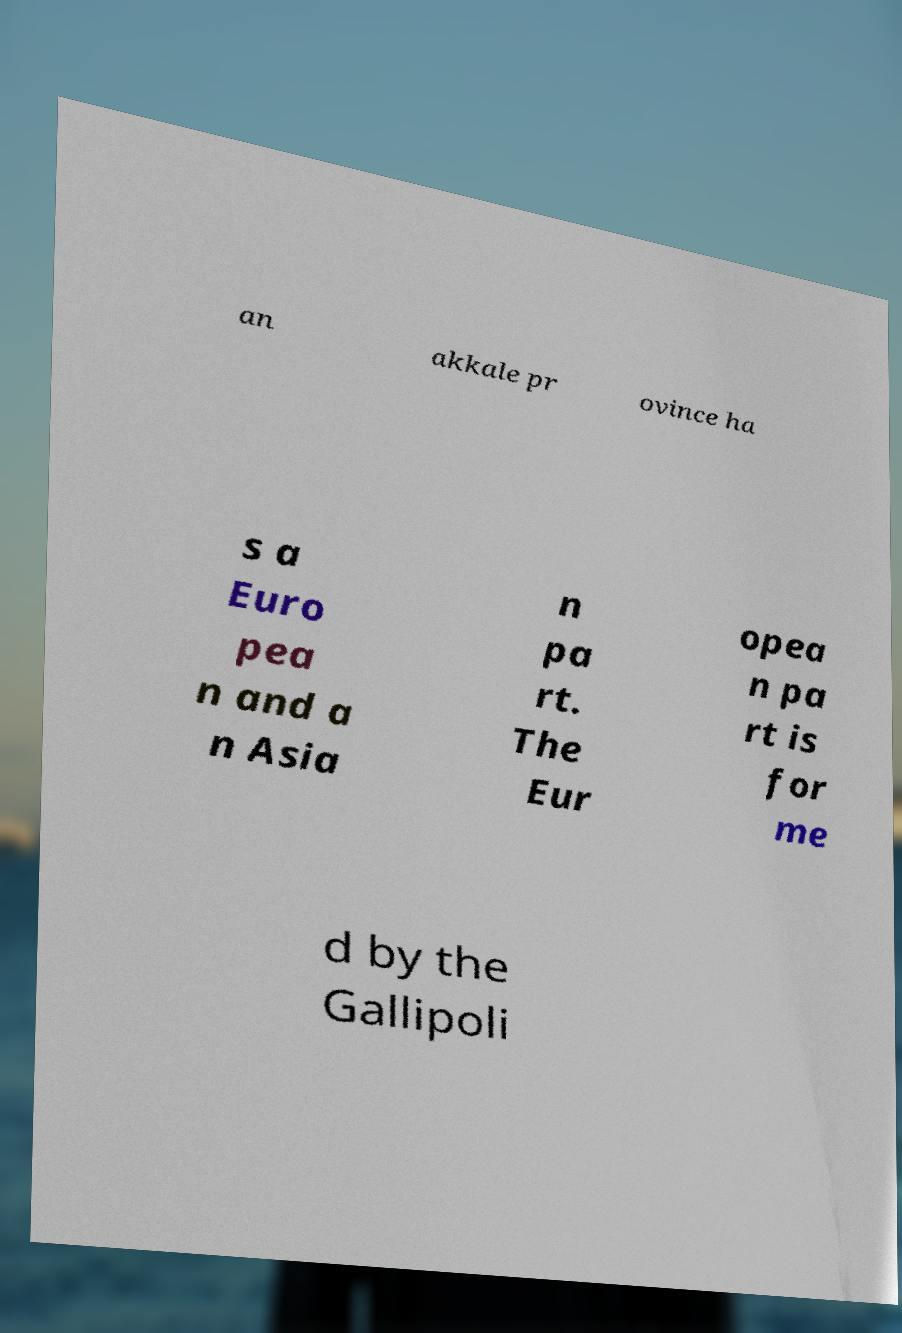Could you assist in decoding the text presented in this image and type it out clearly? an akkale pr ovince ha s a Euro pea n and a n Asia n pa rt. The Eur opea n pa rt is for me d by the Gallipoli 